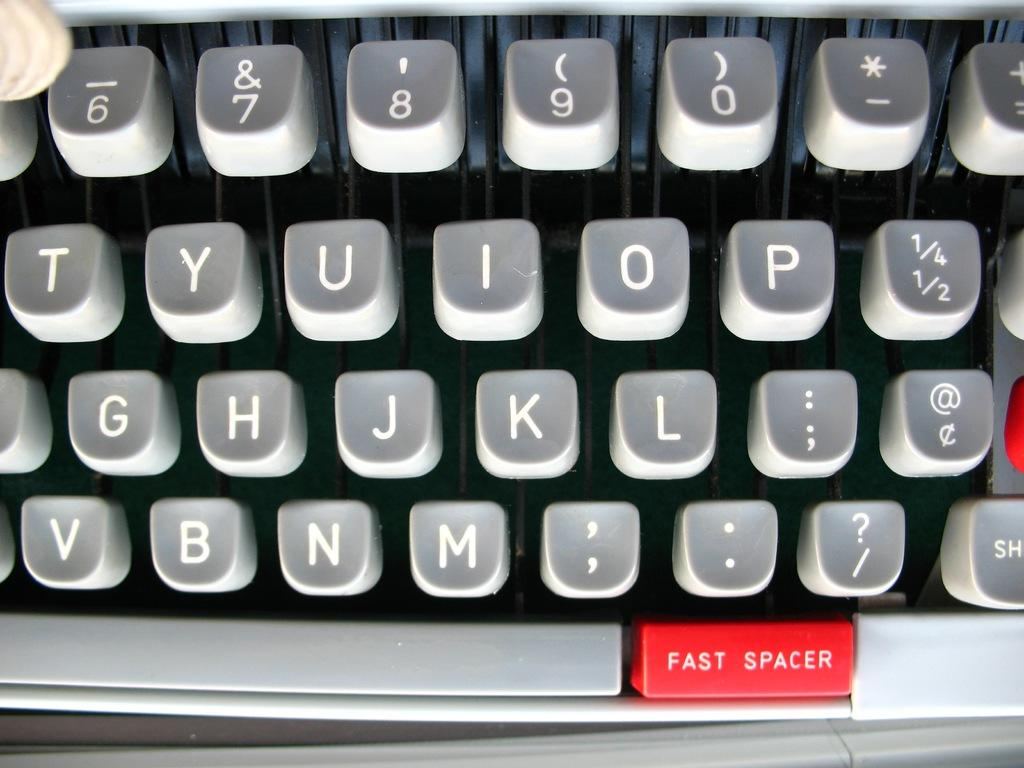<image>
Offer a succinct explanation of the picture presented. The keyboard of a type writer is shown with a red button labeled fast spacer at the bottom. 